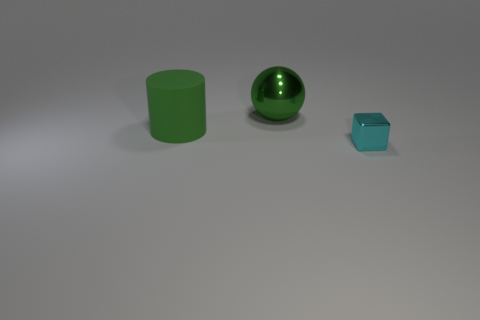What does the arrangement of the objects suggest? The objects are spaced with a sense of deliberation, potentially indicating a comparison of forms in decreasing size order, which might be an artistic exploration of scale and proportion. How could this image be used in an educational setting? This image could be utilized to teach geometric shapes and volumes, principles of light and shadow in art, or even as a prompt for a creative storytelling exercise, allowing students to invent narratives based upon the objects. 